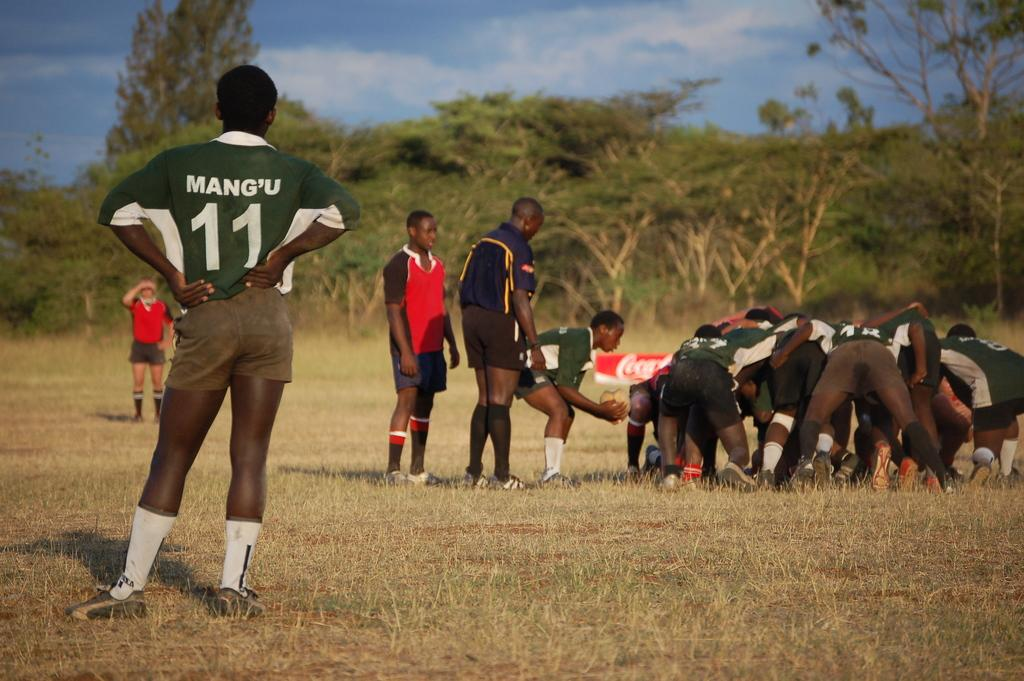<image>
Describe the image concisely. Man wearing a green number 11 jersey watching others. 